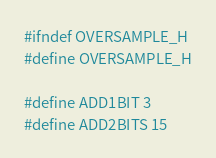Convert code to text. <code><loc_0><loc_0><loc_500><loc_500><_C_>#ifndef OVERSAMPLE_H
#define OVERSAMPLE_H

#define ADD1BIT 3
#define ADD2BITS 15</code> 